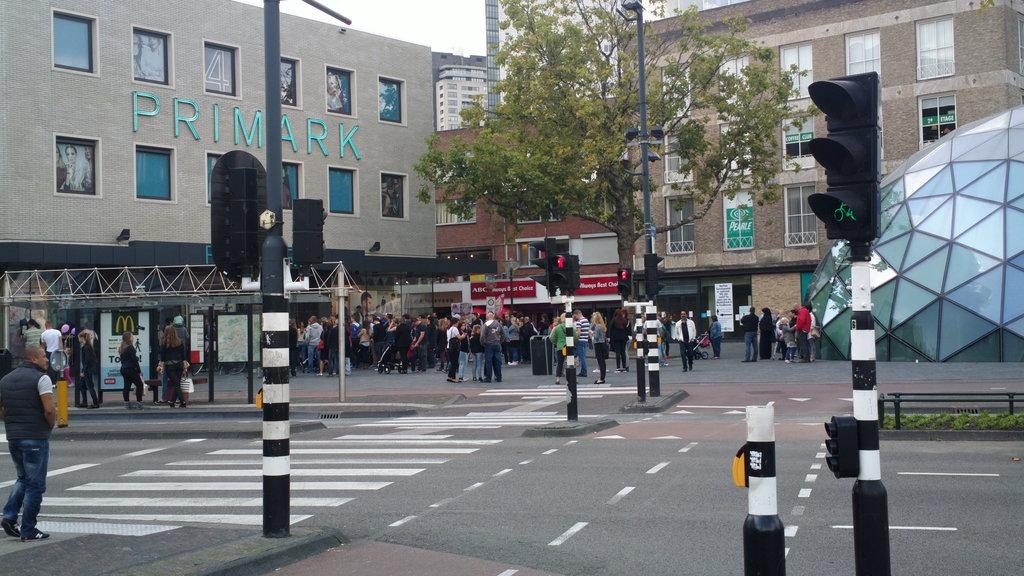What type of signals are present in the image? There are traffic signals in the image. What natural element is visible in the image? There is a tree in the image. What type of structures can be seen in the image? There are buildings in the image. What are the people in the image doing? People are standing on the road in front of the building. What type of jam is being spread on the tree in the image? There is no jam or spreading activity present in the image; it features traffic signals, a tree, buildings, and people standing on the road. How does the cough of the person in the image affect the traffic signals? There is no person coughing in the image, and the traffic signals are not affected by any cough. 